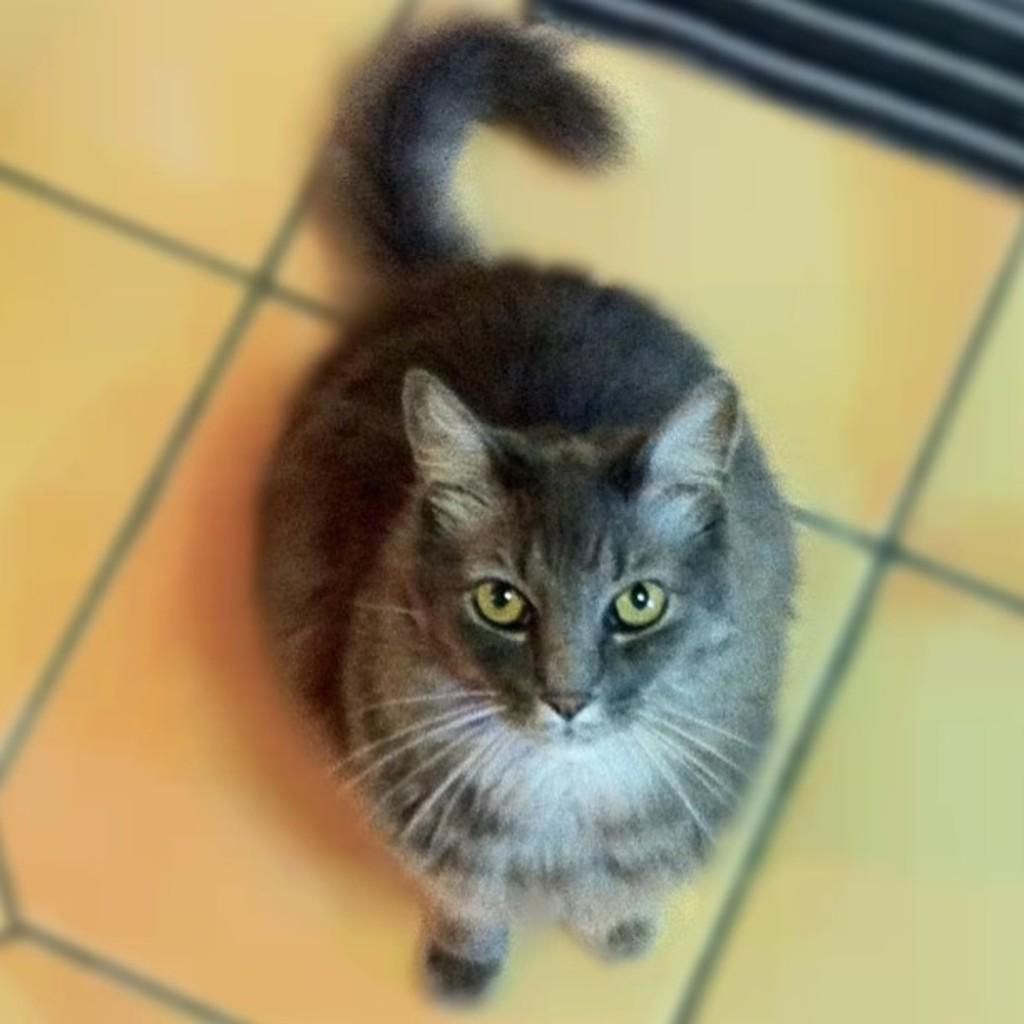What animal is present in the image? There is a cat in the image. What color is the cat? The cat is black in color. Where is the cat located in the image? The cat is sitting on the floor. What is the color of the top right corner of the image? The right top of the image is black in color. What is the cat's focus in the image? The cat is looking at the camera. What type of glass is the cat drinking from in the image? There is no glass present in the image, and the cat is not drinking from anything. 